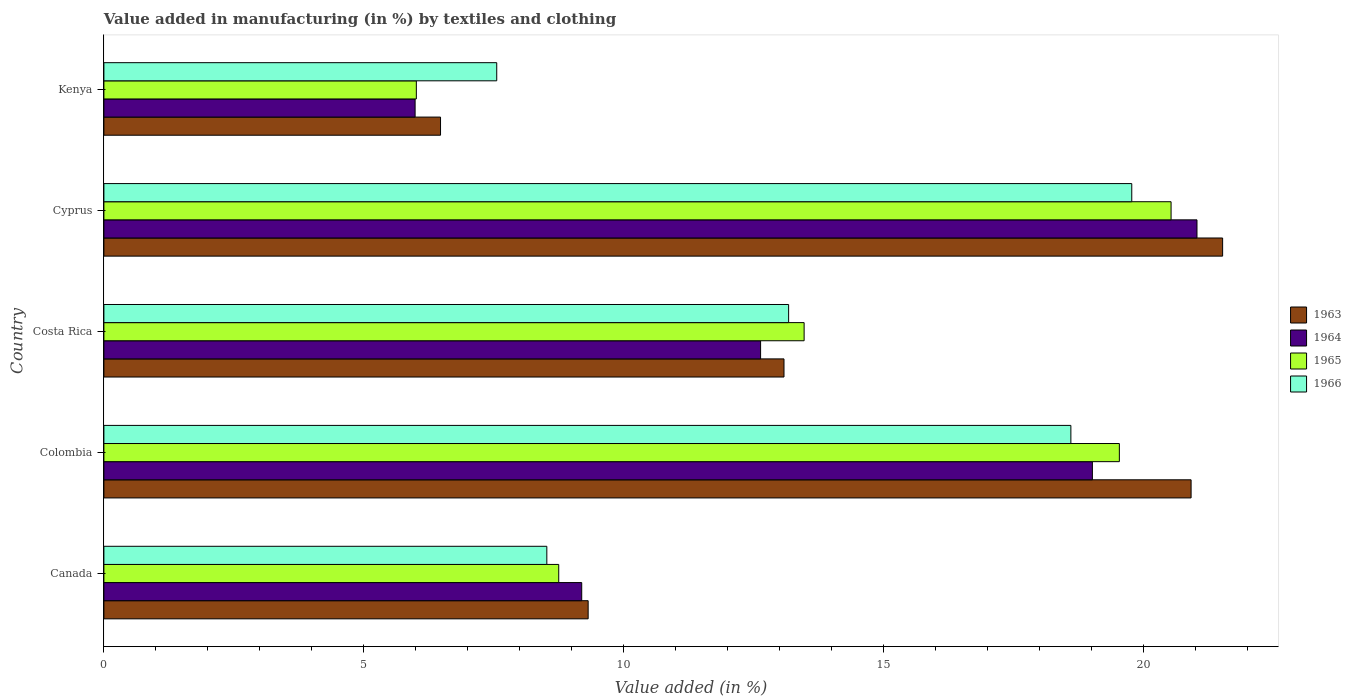How many groups of bars are there?
Ensure brevity in your answer.  5. Are the number of bars on each tick of the Y-axis equal?
Offer a terse response. Yes. How many bars are there on the 2nd tick from the top?
Make the answer very short. 4. How many bars are there on the 3rd tick from the bottom?
Ensure brevity in your answer.  4. In how many cases, is the number of bars for a given country not equal to the number of legend labels?
Your answer should be very brief. 0. What is the percentage of value added in manufacturing by textiles and clothing in 1965 in Canada?
Offer a terse response. 8.75. Across all countries, what is the maximum percentage of value added in manufacturing by textiles and clothing in 1965?
Your answer should be very brief. 20.53. Across all countries, what is the minimum percentage of value added in manufacturing by textiles and clothing in 1966?
Keep it short and to the point. 7.56. In which country was the percentage of value added in manufacturing by textiles and clothing in 1964 maximum?
Provide a succinct answer. Cyprus. In which country was the percentage of value added in manufacturing by textiles and clothing in 1965 minimum?
Your response must be concise. Kenya. What is the total percentage of value added in manufacturing by textiles and clothing in 1964 in the graph?
Keep it short and to the point. 67.86. What is the difference between the percentage of value added in manufacturing by textiles and clothing in 1966 in Canada and that in Kenya?
Provide a succinct answer. 0.96. What is the difference between the percentage of value added in manufacturing by textiles and clothing in 1966 in Colombia and the percentage of value added in manufacturing by textiles and clothing in 1964 in Kenya?
Provide a short and direct response. 12.62. What is the average percentage of value added in manufacturing by textiles and clothing in 1963 per country?
Your answer should be very brief. 14.26. What is the difference between the percentage of value added in manufacturing by textiles and clothing in 1966 and percentage of value added in manufacturing by textiles and clothing in 1964 in Cyprus?
Ensure brevity in your answer.  -1.25. What is the ratio of the percentage of value added in manufacturing by textiles and clothing in 1964 in Colombia to that in Kenya?
Offer a very short reply. 3.18. Is the difference between the percentage of value added in manufacturing by textiles and clothing in 1966 in Colombia and Cyprus greater than the difference between the percentage of value added in manufacturing by textiles and clothing in 1964 in Colombia and Cyprus?
Your answer should be very brief. Yes. What is the difference between the highest and the second highest percentage of value added in manufacturing by textiles and clothing in 1964?
Offer a very short reply. 2.01. What is the difference between the highest and the lowest percentage of value added in manufacturing by textiles and clothing in 1965?
Keep it short and to the point. 14.52. Is the sum of the percentage of value added in manufacturing by textiles and clothing in 1965 in Colombia and Costa Rica greater than the maximum percentage of value added in manufacturing by textiles and clothing in 1963 across all countries?
Make the answer very short. Yes. What does the 1st bar from the top in Kenya represents?
Provide a short and direct response. 1966. What does the 1st bar from the bottom in Kenya represents?
Offer a very short reply. 1963. Is it the case that in every country, the sum of the percentage of value added in manufacturing by textiles and clothing in 1963 and percentage of value added in manufacturing by textiles and clothing in 1964 is greater than the percentage of value added in manufacturing by textiles and clothing in 1965?
Keep it short and to the point. Yes. How many countries are there in the graph?
Your answer should be very brief. 5. Are the values on the major ticks of X-axis written in scientific E-notation?
Your response must be concise. No. What is the title of the graph?
Your response must be concise. Value added in manufacturing (in %) by textiles and clothing. What is the label or title of the X-axis?
Your answer should be compact. Value added (in %). What is the label or title of the Y-axis?
Make the answer very short. Country. What is the Value added (in %) of 1963 in Canada?
Your answer should be compact. 9.32. What is the Value added (in %) in 1964 in Canada?
Provide a succinct answer. 9.19. What is the Value added (in %) of 1965 in Canada?
Offer a very short reply. 8.75. What is the Value added (in %) of 1966 in Canada?
Ensure brevity in your answer.  8.52. What is the Value added (in %) of 1963 in Colombia?
Keep it short and to the point. 20.92. What is the Value added (in %) in 1964 in Colombia?
Offer a very short reply. 19.02. What is the Value added (in %) in 1965 in Colombia?
Your answer should be very brief. 19.54. What is the Value added (in %) of 1966 in Colombia?
Keep it short and to the point. 18.6. What is the Value added (in %) of 1963 in Costa Rica?
Give a very brief answer. 13.08. What is the Value added (in %) of 1964 in Costa Rica?
Make the answer very short. 12.63. What is the Value added (in %) of 1965 in Costa Rica?
Your response must be concise. 13.47. What is the Value added (in %) of 1966 in Costa Rica?
Your answer should be compact. 13.17. What is the Value added (in %) in 1963 in Cyprus?
Give a very brief answer. 21.52. What is the Value added (in %) in 1964 in Cyprus?
Make the answer very short. 21.03. What is the Value added (in %) in 1965 in Cyprus?
Make the answer very short. 20.53. What is the Value added (in %) of 1966 in Cyprus?
Provide a short and direct response. 19.78. What is the Value added (in %) in 1963 in Kenya?
Give a very brief answer. 6.48. What is the Value added (in %) of 1964 in Kenya?
Keep it short and to the point. 5.99. What is the Value added (in %) of 1965 in Kenya?
Make the answer very short. 6.01. What is the Value added (in %) in 1966 in Kenya?
Offer a very short reply. 7.56. Across all countries, what is the maximum Value added (in %) of 1963?
Ensure brevity in your answer.  21.52. Across all countries, what is the maximum Value added (in %) in 1964?
Ensure brevity in your answer.  21.03. Across all countries, what is the maximum Value added (in %) in 1965?
Provide a short and direct response. 20.53. Across all countries, what is the maximum Value added (in %) of 1966?
Ensure brevity in your answer.  19.78. Across all countries, what is the minimum Value added (in %) of 1963?
Provide a succinct answer. 6.48. Across all countries, what is the minimum Value added (in %) in 1964?
Make the answer very short. 5.99. Across all countries, what is the minimum Value added (in %) of 1965?
Your response must be concise. 6.01. Across all countries, what is the minimum Value added (in %) of 1966?
Provide a succinct answer. 7.56. What is the total Value added (in %) of 1963 in the graph?
Provide a short and direct response. 71.32. What is the total Value added (in %) in 1964 in the graph?
Offer a very short reply. 67.86. What is the total Value added (in %) in 1965 in the graph?
Offer a terse response. 68.3. What is the total Value added (in %) of 1966 in the graph?
Your answer should be very brief. 67.63. What is the difference between the Value added (in %) in 1963 in Canada and that in Colombia?
Provide a short and direct response. -11.6. What is the difference between the Value added (in %) in 1964 in Canada and that in Colombia?
Give a very brief answer. -9.82. What is the difference between the Value added (in %) of 1965 in Canada and that in Colombia?
Your response must be concise. -10.79. What is the difference between the Value added (in %) in 1966 in Canada and that in Colombia?
Offer a very short reply. -10.08. What is the difference between the Value added (in %) in 1963 in Canada and that in Costa Rica?
Ensure brevity in your answer.  -3.77. What is the difference between the Value added (in %) of 1964 in Canada and that in Costa Rica?
Your answer should be very brief. -3.44. What is the difference between the Value added (in %) in 1965 in Canada and that in Costa Rica?
Your answer should be very brief. -4.72. What is the difference between the Value added (in %) in 1966 in Canada and that in Costa Rica?
Offer a very short reply. -4.65. What is the difference between the Value added (in %) of 1963 in Canada and that in Cyprus?
Ensure brevity in your answer.  -12.21. What is the difference between the Value added (in %) in 1964 in Canada and that in Cyprus?
Your answer should be compact. -11.84. What is the difference between the Value added (in %) in 1965 in Canada and that in Cyprus?
Ensure brevity in your answer.  -11.78. What is the difference between the Value added (in %) of 1966 in Canada and that in Cyprus?
Provide a succinct answer. -11.25. What is the difference between the Value added (in %) of 1963 in Canada and that in Kenya?
Give a very brief answer. 2.84. What is the difference between the Value added (in %) of 1964 in Canada and that in Kenya?
Provide a succinct answer. 3.21. What is the difference between the Value added (in %) of 1965 in Canada and that in Kenya?
Provide a succinct answer. 2.74. What is the difference between the Value added (in %) of 1966 in Canada and that in Kenya?
Your answer should be compact. 0.96. What is the difference between the Value added (in %) of 1963 in Colombia and that in Costa Rica?
Give a very brief answer. 7.83. What is the difference between the Value added (in %) in 1964 in Colombia and that in Costa Rica?
Make the answer very short. 6.38. What is the difference between the Value added (in %) of 1965 in Colombia and that in Costa Rica?
Keep it short and to the point. 6.06. What is the difference between the Value added (in %) in 1966 in Colombia and that in Costa Rica?
Provide a succinct answer. 5.43. What is the difference between the Value added (in %) of 1963 in Colombia and that in Cyprus?
Give a very brief answer. -0.61. What is the difference between the Value added (in %) in 1964 in Colombia and that in Cyprus?
Provide a succinct answer. -2.01. What is the difference between the Value added (in %) of 1965 in Colombia and that in Cyprus?
Your answer should be very brief. -0.99. What is the difference between the Value added (in %) of 1966 in Colombia and that in Cyprus?
Provide a succinct answer. -1.17. What is the difference between the Value added (in %) of 1963 in Colombia and that in Kenya?
Provide a succinct answer. 14.44. What is the difference between the Value added (in %) of 1964 in Colombia and that in Kenya?
Your answer should be very brief. 13.03. What is the difference between the Value added (in %) of 1965 in Colombia and that in Kenya?
Provide a short and direct response. 13.53. What is the difference between the Value added (in %) in 1966 in Colombia and that in Kenya?
Give a very brief answer. 11.05. What is the difference between the Value added (in %) in 1963 in Costa Rica and that in Cyprus?
Your response must be concise. -8.44. What is the difference between the Value added (in %) in 1964 in Costa Rica and that in Cyprus?
Offer a terse response. -8.4. What is the difference between the Value added (in %) of 1965 in Costa Rica and that in Cyprus?
Provide a short and direct response. -7.06. What is the difference between the Value added (in %) of 1966 in Costa Rica and that in Cyprus?
Offer a very short reply. -6.6. What is the difference between the Value added (in %) of 1963 in Costa Rica and that in Kenya?
Your response must be concise. 6.61. What is the difference between the Value added (in %) of 1964 in Costa Rica and that in Kenya?
Your answer should be very brief. 6.65. What is the difference between the Value added (in %) of 1965 in Costa Rica and that in Kenya?
Your answer should be compact. 7.46. What is the difference between the Value added (in %) of 1966 in Costa Rica and that in Kenya?
Your response must be concise. 5.62. What is the difference between the Value added (in %) in 1963 in Cyprus and that in Kenya?
Your answer should be compact. 15.05. What is the difference between the Value added (in %) in 1964 in Cyprus and that in Kenya?
Your answer should be compact. 15.04. What is the difference between the Value added (in %) of 1965 in Cyprus and that in Kenya?
Your answer should be very brief. 14.52. What is the difference between the Value added (in %) in 1966 in Cyprus and that in Kenya?
Keep it short and to the point. 12.22. What is the difference between the Value added (in %) in 1963 in Canada and the Value added (in %) in 1964 in Colombia?
Ensure brevity in your answer.  -9.7. What is the difference between the Value added (in %) in 1963 in Canada and the Value added (in %) in 1965 in Colombia?
Your answer should be compact. -10.22. What is the difference between the Value added (in %) in 1963 in Canada and the Value added (in %) in 1966 in Colombia?
Keep it short and to the point. -9.29. What is the difference between the Value added (in %) of 1964 in Canada and the Value added (in %) of 1965 in Colombia?
Keep it short and to the point. -10.34. What is the difference between the Value added (in %) in 1964 in Canada and the Value added (in %) in 1966 in Colombia?
Your answer should be very brief. -9.41. What is the difference between the Value added (in %) of 1965 in Canada and the Value added (in %) of 1966 in Colombia?
Keep it short and to the point. -9.85. What is the difference between the Value added (in %) of 1963 in Canada and the Value added (in %) of 1964 in Costa Rica?
Provide a short and direct response. -3.32. What is the difference between the Value added (in %) of 1963 in Canada and the Value added (in %) of 1965 in Costa Rica?
Offer a terse response. -4.16. What is the difference between the Value added (in %) of 1963 in Canada and the Value added (in %) of 1966 in Costa Rica?
Provide a short and direct response. -3.86. What is the difference between the Value added (in %) of 1964 in Canada and the Value added (in %) of 1965 in Costa Rica?
Keep it short and to the point. -4.28. What is the difference between the Value added (in %) of 1964 in Canada and the Value added (in %) of 1966 in Costa Rica?
Offer a terse response. -3.98. What is the difference between the Value added (in %) in 1965 in Canada and the Value added (in %) in 1966 in Costa Rica?
Your answer should be very brief. -4.42. What is the difference between the Value added (in %) in 1963 in Canada and the Value added (in %) in 1964 in Cyprus?
Provide a short and direct response. -11.71. What is the difference between the Value added (in %) of 1963 in Canada and the Value added (in %) of 1965 in Cyprus?
Offer a very short reply. -11.21. What is the difference between the Value added (in %) of 1963 in Canada and the Value added (in %) of 1966 in Cyprus?
Make the answer very short. -10.46. What is the difference between the Value added (in %) of 1964 in Canada and the Value added (in %) of 1965 in Cyprus?
Offer a very short reply. -11.34. What is the difference between the Value added (in %) of 1964 in Canada and the Value added (in %) of 1966 in Cyprus?
Ensure brevity in your answer.  -10.58. What is the difference between the Value added (in %) of 1965 in Canada and the Value added (in %) of 1966 in Cyprus?
Keep it short and to the point. -11.02. What is the difference between the Value added (in %) in 1963 in Canada and the Value added (in %) in 1964 in Kenya?
Offer a terse response. 3.33. What is the difference between the Value added (in %) of 1963 in Canada and the Value added (in %) of 1965 in Kenya?
Your answer should be compact. 3.31. What is the difference between the Value added (in %) in 1963 in Canada and the Value added (in %) in 1966 in Kenya?
Ensure brevity in your answer.  1.76. What is the difference between the Value added (in %) of 1964 in Canada and the Value added (in %) of 1965 in Kenya?
Provide a short and direct response. 3.18. What is the difference between the Value added (in %) of 1964 in Canada and the Value added (in %) of 1966 in Kenya?
Ensure brevity in your answer.  1.64. What is the difference between the Value added (in %) in 1965 in Canada and the Value added (in %) in 1966 in Kenya?
Provide a short and direct response. 1.19. What is the difference between the Value added (in %) of 1963 in Colombia and the Value added (in %) of 1964 in Costa Rica?
Your answer should be compact. 8.28. What is the difference between the Value added (in %) of 1963 in Colombia and the Value added (in %) of 1965 in Costa Rica?
Offer a terse response. 7.44. What is the difference between the Value added (in %) in 1963 in Colombia and the Value added (in %) in 1966 in Costa Rica?
Offer a terse response. 7.74. What is the difference between the Value added (in %) of 1964 in Colombia and the Value added (in %) of 1965 in Costa Rica?
Offer a very short reply. 5.55. What is the difference between the Value added (in %) of 1964 in Colombia and the Value added (in %) of 1966 in Costa Rica?
Provide a succinct answer. 5.84. What is the difference between the Value added (in %) of 1965 in Colombia and the Value added (in %) of 1966 in Costa Rica?
Your response must be concise. 6.36. What is the difference between the Value added (in %) of 1963 in Colombia and the Value added (in %) of 1964 in Cyprus?
Your answer should be very brief. -0.11. What is the difference between the Value added (in %) in 1963 in Colombia and the Value added (in %) in 1965 in Cyprus?
Your answer should be compact. 0.39. What is the difference between the Value added (in %) of 1963 in Colombia and the Value added (in %) of 1966 in Cyprus?
Provide a short and direct response. 1.14. What is the difference between the Value added (in %) in 1964 in Colombia and the Value added (in %) in 1965 in Cyprus?
Your answer should be very brief. -1.51. What is the difference between the Value added (in %) of 1964 in Colombia and the Value added (in %) of 1966 in Cyprus?
Make the answer very short. -0.76. What is the difference between the Value added (in %) of 1965 in Colombia and the Value added (in %) of 1966 in Cyprus?
Provide a short and direct response. -0.24. What is the difference between the Value added (in %) of 1963 in Colombia and the Value added (in %) of 1964 in Kenya?
Your answer should be very brief. 14.93. What is the difference between the Value added (in %) of 1963 in Colombia and the Value added (in %) of 1965 in Kenya?
Offer a very short reply. 14.91. What is the difference between the Value added (in %) in 1963 in Colombia and the Value added (in %) in 1966 in Kenya?
Offer a terse response. 13.36. What is the difference between the Value added (in %) in 1964 in Colombia and the Value added (in %) in 1965 in Kenya?
Ensure brevity in your answer.  13.01. What is the difference between the Value added (in %) of 1964 in Colombia and the Value added (in %) of 1966 in Kenya?
Give a very brief answer. 11.46. What is the difference between the Value added (in %) in 1965 in Colombia and the Value added (in %) in 1966 in Kenya?
Provide a short and direct response. 11.98. What is the difference between the Value added (in %) in 1963 in Costa Rica and the Value added (in %) in 1964 in Cyprus?
Make the answer very short. -7.95. What is the difference between the Value added (in %) of 1963 in Costa Rica and the Value added (in %) of 1965 in Cyprus?
Your answer should be very brief. -7.45. What is the difference between the Value added (in %) in 1963 in Costa Rica and the Value added (in %) in 1966 in Cyprus?
Give a very brief answer. -6.69. What is the difference between the Value added (in %) of 1964 in Costa Rica and the Value added (in %) of 1965 in Cyprus?
Provide a short and direct response. -7.9. What is the difference between the Value added (in %) in 1964 in Costa Rica and the Value added (in %) in 1966 in Cyprus?
Make the answer very short. -7.14. What is the difference between the Value added (in %) of 1965 in Costa Rica and the Value added (in %) of 1966 in Cyprus?
Offer a very short reply. -6.3. What is the difference between the Value added (in %) in 1963 in Costa Rica and the Value added (in %) in 1964 in Kenya?
Offer a terse response. 7.1. What is the difference between the Value added (in %) of 1963 in Costa Rica and the Value added (in %) of 1965 in Kenya?
Your response must be concise. 7.07. What is the difference between the Value added (in %) in 1963 in Costa Rica and the Value added (in %) in 1966 in Kenya?
Provide a short and direct response. 5.53. What is the difference between the Value added (in %) in 1964 in Costa Rica and the Value added (in %) in 1965 in Kenya?
Provide a succinct answer. 6.62. What is the difference between the Value added (in %) in 1964 in Costa Rica and the Value added (in %) in 1966 in Kenya?
Make the answer very short. 5.08. What is the difference between the Value added (in %) of 1965 in Costa Rica and the Value added (in %) of 1966 in Kenya?
Your answer should be compact. 5.91. What is the difference between the Value added (in %) in 1963 in Cyprus and the Value added (in %) in 1964 in Kenya?
Offer a terse response. 15.54. What is the difference between the Value added (in %) of 1963 in Cyprus and the Value added (in %) of 1965 in Kenya?
Make the answer very short. 15.51. What is the difference between the Value added (in %) in 1963 in Cyprus and the Value added (in %) in 1966 in Kenya?
Your answer should be very brief. 13.97. What is the difference between the Value added (in %) of 1964 in Cyprus and the Value added (in %) of 1965 in Kenya?
Give a very brief answer. 15.02. What is the difference between the Value added (in %) in 1964 in Cyprus and the Value added (in %) in 1966 in Kenya?
Provide a short and direct response. 13.47. What is the difference between the Value added (in %) of 1965 in Cyprus and the Value added (in %) of 1966 in Kenya?
Your response must be concise. 12.97. What is the average Value added (in %) in 1963 per country?
Your answer should be compact. 14.26. What is the average Value added (in %) of 1964 per country?
Offer a terse response. 13.57. What is the average Value added (in %) of 1965 per country?
Your answer should be very brief. 13.66. What is the average Value added (in %) of 1966 per country?
Your response must be concise. 13.53. What is the difference between the Value added (in %) of 1963 and Value added (in %) of 1964 in Canada?
Provide a succinct answer. 0.12. What is the difference between the Value added (in %) in 1963 and Value added (in %) in 1965 in Canada?
Provide a short and direct response. 0.57. What is the difference between the Value added (in %) in 1963 and Value added (in %) in 1966 in Canada?
Provide a succinct answer. 0.8. What is the difference between the Value added (in %) of 1964 and Value added (in %) of 1965 in Canada?
Ensure brevity in your answer.  0.44. What is the difference between the Value added (in %) of 1964 and Value added (in %) of 1966 in Canada?
Provide a succinct answer. 0.67. What is the difference between the Value added (in %) in 1965 and Value added (in %) in 1966 in Canada?
Make the answer very short. 0.23. What is the difference between the Value added (in %) of 1963 and Value added (in %) of 1964 in Colombia?
Provide a succinct answer. 1.9. What is the difference between the Value added (in %) in 1963 and Value added (in %) in 1965 in Colombia?
Offer a terse response. 1.38. What is the difference between the Value added (in %) of 1963 and Value added (in %) of 1966 in Colombia?
Keep it short and to the point. 2.31. What is the difference between the Value added (in %) in 1964 and Value added (in %) in 1965 in Colombia?
Give a very brief answer. -0.52. What is the difference between the Value added (in %) of 1964 and Value added (in %) of 1966 in Colombia?
Provide a succinct answer. 0.41. What is the difference between the Value added (in %) of 1965 and Value added (in %) of 1966 in Colombia?
Your answer should be very brief. 0.93. What is the difference between the Value added (in %) of 1963 and Value added (in %) of 1964 in Costa Rica?
Offer a very short reply. 0.45. What is the difference between the Value added (in %) of 1963 and Value added (in %) of 1965 in Costa Rica?
Offer a terse response. -0.39. What is the difference between the Value added (in %) in 1963 and Value added (in %) in 1966 in Costa Rica?
Your answer should be very brief. -0.09. What is the difference between the Value added (in %) of 1964 and Value added (in %) of 1965 in Costa Rica?
Make the answer very short. -0.84. What is the difference between the Value added (in %) in 1964 and Value added (in %) in 1966 in Costa Rica?
Your answer should be very brief. -0.54. What is the difference between the Value added (in %) of 1965 and Value added (in %) of 1966 in Costa Rica?
Your answer should be compact. 0.3. What is the difference between the Value added (in %) of 1963 and Value added (in %) of 1964 in Cyprus?
Ensure brevity in your answer.  0.49. What is the difference between the Value added (in %) in 1963 and Value added (in %) in 1966 in Cyprus?
Give a very brief answer. 1.75. What is the difference between the Value added (in %) in 1964 and Value added (in %) in 1965 in Cyprus?
Offer a terse response. 0.5. What is the difference between the Value added (in %) of 1964 and Value added (in %) of 1966 in Cyprus?
Your answer should be compact. 1.25. What is the difference between the Value added (in %) of 1965 and Value added (in %) of 1966 in Cyprus?
Ensure brevity in your answer.  0.76. What is the difference between the Value added (in %) in 1963 and Value added (in %) in 1964 in Kenya?
Make the answer very short. 0.49. What is the difference between the Value added (in %) in 1963 and Value added (in %) in 1965 in Kenya?
Give a very brief answer. 0.47. What is the difference between the Value added (in %) of 1963 and Value added (in %) of 1966 in Kenya?
Ensure brevity in your answer.  -1.08. What is the difference between the Value added (in %) in 1964 and Value added (in %) in 1965 in Kenya?
Offer a very short reply. -0.02. What is the difference between the Value added (in %) in 1964 and Value added (in %) in 1966 in Kenya?
Give a very brief answer. -1.57. What is the difference between the Value added (in %) of 1965 and Value added (in %) of 1966 in Kenya?
Your answer should be very brief. -1.55. What is the ratio of the Value added (in %) of 1963 in Canada to that in Colombia?
Offer a very short reply. 0.45. What is the ratio of the Value added (in %) in 1964 in Canada to that in Colombia?
Offer a very short reply. 0.48. What is the ratio of the Value added (in %) of 1965 in Canada to that in Colombia?
Your answer should be compact. 0.45. What is the ratio of the Value added (in %) in 1966 in Canada to that in Colombia?
Your answer should be very brief. 0.46. What is the ratio of the Value added (in %) in 1963 in Canada to that in Costa Rica?
Give a very brief answer. 0.71. What is the ratio of the Value added (in %) in 1964 in Canada to that in Costa Rica?
Offer a very short reply. 0.73. What is the ratio of the Value added (in %) of 1965 in Canada to that in Costa Rica?
Ensure brevity in your answer.  0.65. What is the ratio of the Value added (in %) of 1966 in Canada to that in Costa Rica?
Make the answer very short. 0.65. What is the ratio of the Value added (in %) of 1963 in Canada to that in Cyprus?
Provide a succinct answer. 0.43. What is the ratio of the Value added (in %) in 1964 in Canada to that in Cyprus?
Give a very brief answer. 0.44. What is the ratio of the Value added (in %) in 1965 in Canada to that in Cyprus?
Offer a very short reply. 0.43. What is the ratio of the Value added (in %) in 1966 in Canada to that in Cyprus?
Make the answer very short. 0.43. What is the ratio of the Value added (in %) of 1963 in Canada to that in Kenya?
Provide a short and direct response. 1.44. What is the ratio of the Value added (in %) in 1964 in Canada to that in Kenya?
Give a very brief answer. 1.54. What is the ratio of the Value added (in %) of 1965 in Canada to that in Kenya?
Provide a short and direct response. 1.46. What is the ratio of the Value added (in %) in 1966 in Canada to that in Kenya?
Offer a very short reply. 1.13. What is the ratio of the Value added (in %) of 1963 in Colombia to that in Costa Rica?
Offer a terse response. 1.6. What is the ratio of the Value added (in %) in 1964 in Colombia to that in Costa Rica?
Offer a very short reply. 1.51. What is the ratio of the Value added (in %) in 1965 in Colombia to that in Costa Rica?
Your answer should be very brief. 1.45. What is the ratio of the Value added (in %) of 1966 in Colombia to that in Costa Rica?
Your answer should be very brief. 1.41. What is the ratio of the Value added (in %) of 1963 in Colombia to that in Cyprus?
Give a very brief answer. 0.97. What is the ratio of the Value added (in %) in 1964 in Colombia to that in Cyprus?
Provide a short and direct response. 0.9. What is the ratio of the Value added (in %) of 1965 in Colombia to that in Cyprus?
Your answer should be compact. 0.95. What is the ratio of the Value added (in %) in 1966 in Colombia to that in Cyprus?
Provide a short and direct response. 0.94. What is the ratio of the Value added (in %) in 1963 in Colombia to that in Kenya?
Ensure brevity in your answer.  3.23. What is the ratio of the Value added (in %) of 1964 in Colombia to that in Kenya?
Offer a terse response. 3.18. What is the ratio of the Value added (in %) in 1966 in Colombia to that in Kenya?
Make the answer very short. 2.46. What is the ratio of the Value added (in %) of 1963 in Costa Rica to that in Cyprus?
Offer a terse response. 0.61. What is the ratio of the Value added (in %) in 1964 in Costa Rica to that in Cyprus?
Offer a terse response. 0.6. What is the ratio of the Value added (in %) in 1965 in Costa Rica to that in Cyprus?
Keep it short and to the point. 0.66. What is the ratio of the Value added (in %) in 1966 in Costa Rica to that in Cyprus?
Your answer should be very brief. 0.67. What is the ratio of the Value added (in %) in 1963 in Costa Rica to that in Kenya?
Make the answer very short. 2.02. What is the ratio of the Value added (in %) of 1964 in Costa Rica to that in Kenya?
Your response must be concise. 2.11. What is the ratio of the Value added (in %) of 1965 in Costa Rica to that in Kenya?
Keep it short and to the point. 2.24. What is the ratio of the Value added (in %) in 1966 in Costa Rica to that in Kenya?
Your response must be concise. 1.74. What is the ratio of the Value added (in %) in 1963 in Cyprus to that in Kenya?
Ensure brevity in your answer.  3.32. What is the ratio of the Value added (in %) in 1964 in Cyprus to that in Kenya?
Ensure brevity in your answer.  3.51. What is the ratio of the Value added (in %) in 1965 in Cyprus to that in Kenya?
Your response must be concise. 3.42. What is the ratio of the Value added (in %) in 1966 in Cyprus to that in Kenya?
Provide a short and direct response. 2.62. What is the difference between the highest and the second highest Value added (in %) of 1963?
Make the answer very short. 0.61. What is the difference between the highest and the second highest Value added (in %) of 1964?
Provide a short and direct response. 2.01. What is the difference between the highest and the second highest Value added (in %) in 1965?
Make the answer very short. 0.99. What is the difference between the highest and the second highest Value added (in %) of 1966?
Provide a succinct answer. 1.17. What is the difference between the highest and the lowest Value added (in %) in 1963?
Make the answer very short. 15.05. What is the difference between the highest and the lowest Value added (in %) in 1964?
Your answer should be very brief. 15.04. What is the difference between the highest and the lowest Value added (in %) in 1965?
Provide a succinct answer. 14.52. What is the difference between the highest and the lowest Value added (in %) in 1966?
Provide a succinct answer. 12.22. 